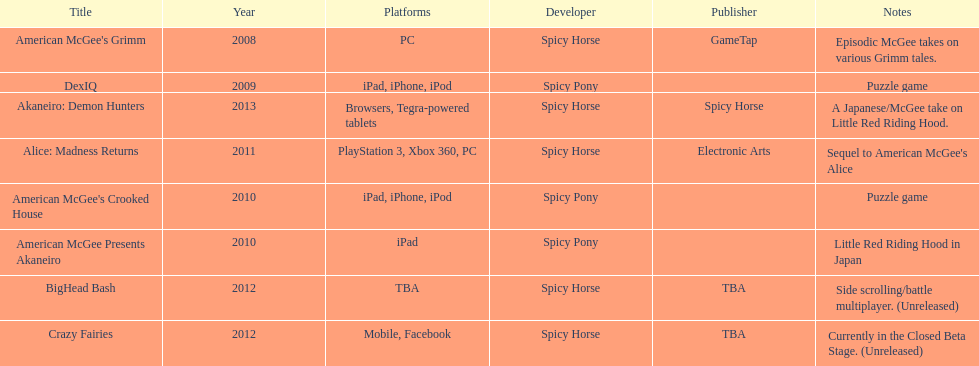How many platforms were compatible with american mcgee's grimm? 1. 